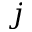<formula> <loc_0><loc_0><loc_500><loc_500>j</formula> 